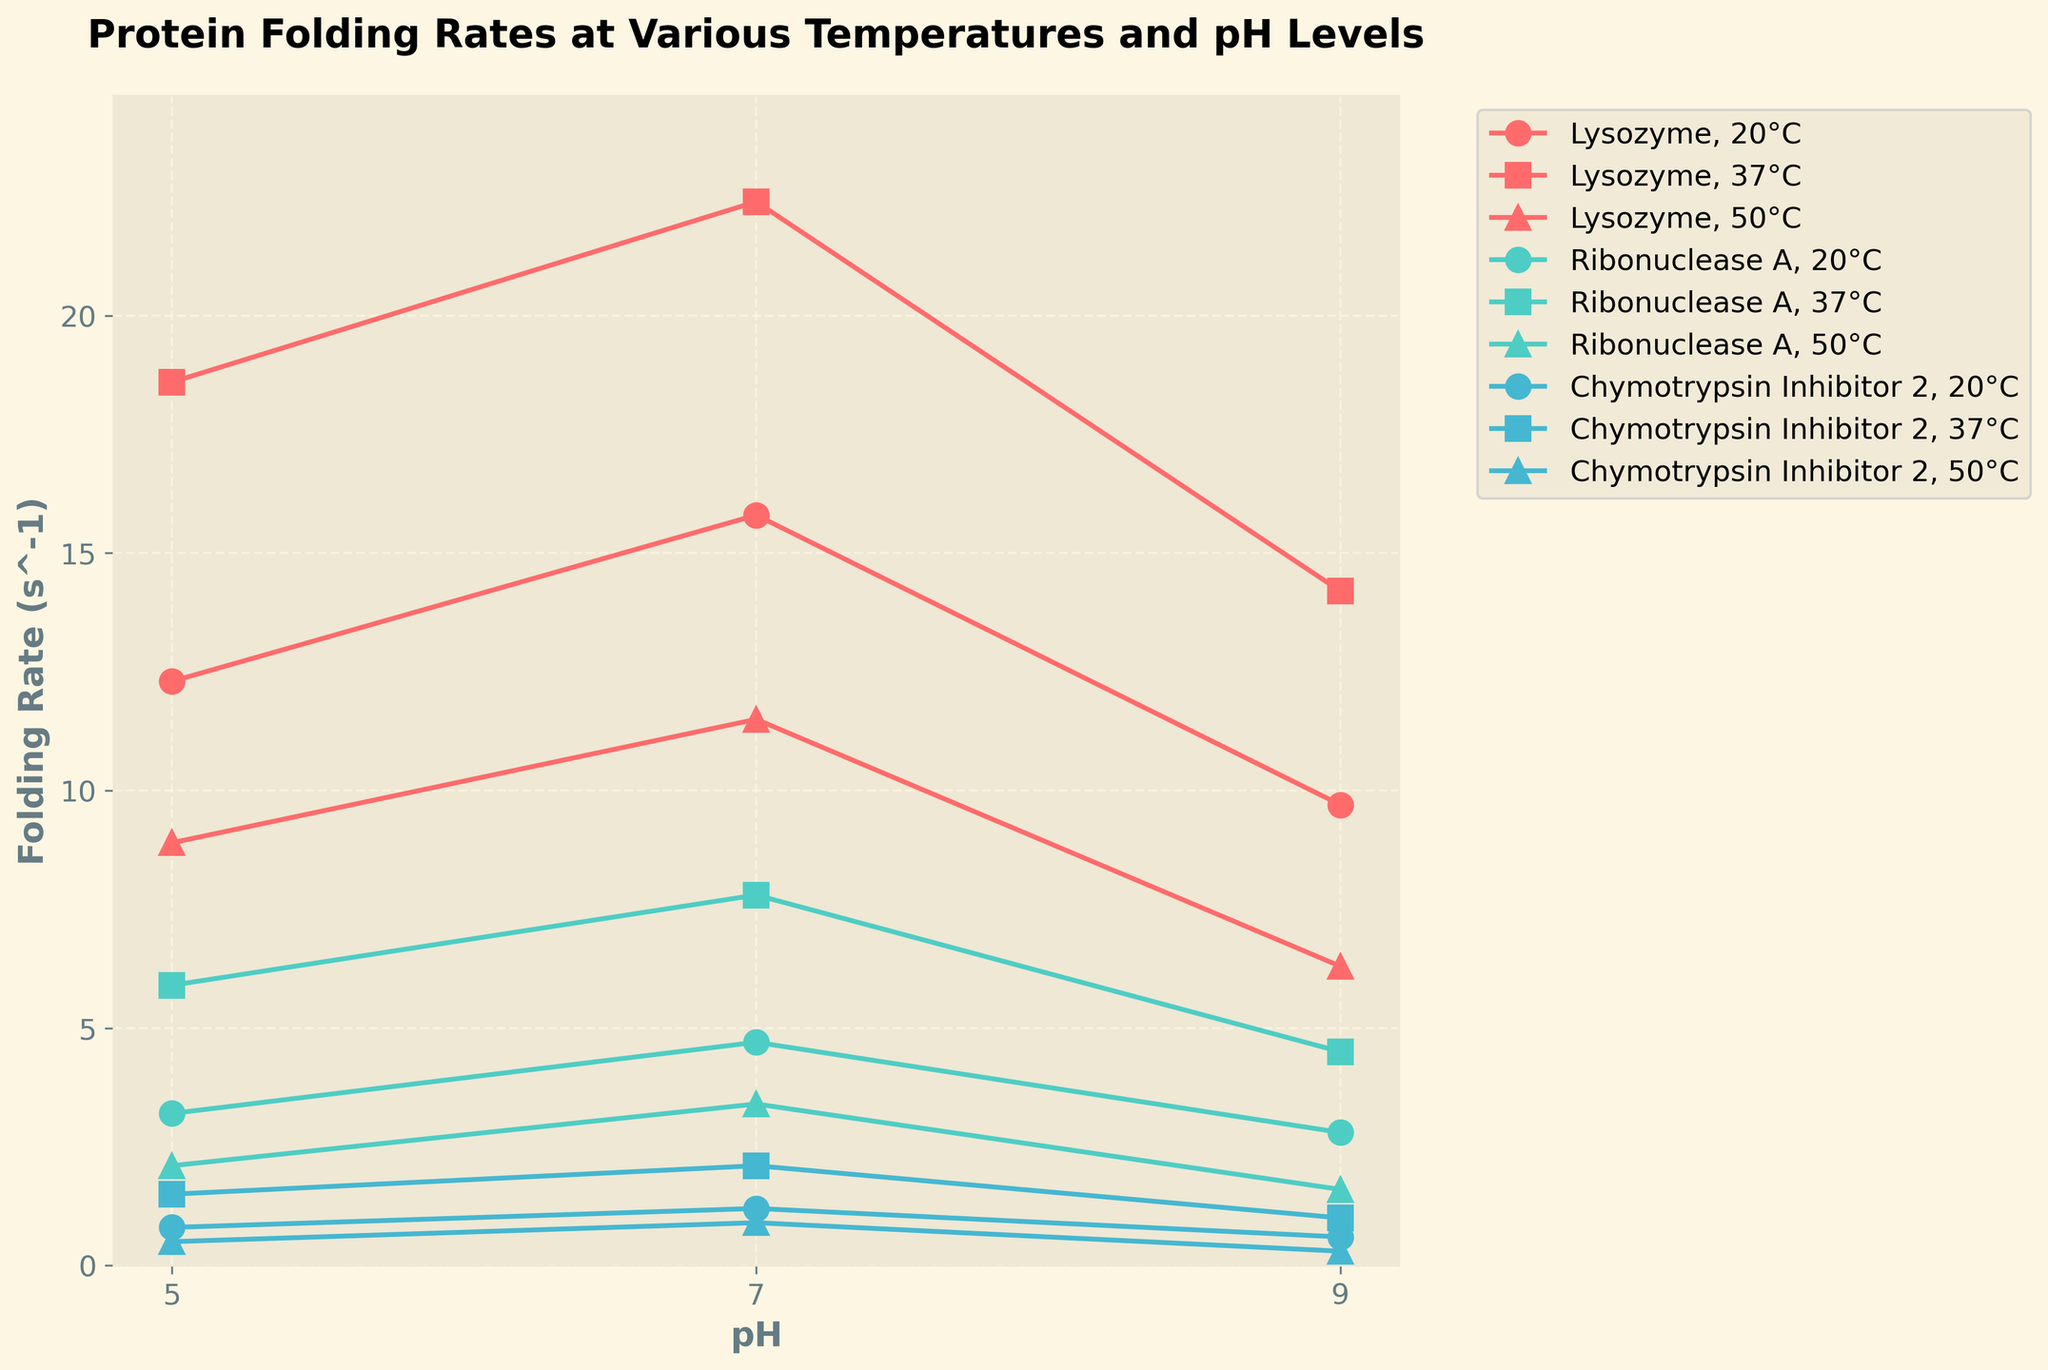What's the highest folding rate observed for Lysozyme at 37°C? First, locate the curve for Lysozyme at 37°C, indicated by its color and marker. Then, identify the peak value on the y-axis corresponding to pH levels. The highest folding rate at 37°C for Lysozyme is 22.4 s^-1 at pH 7.0.
Answer: 22.4 s^-1 How does the folding rate of Ribonuclease A at pH 5.0 change with temperature? Examine the folding rates for Ribonuclease A at pH 5.0 across different temperatures. At 20°C, the rate is 3.2 s^-1; at 37°C, it is 5.9 s^-1, and at 50°C, it drops to 2.1 s^-1. Thus, the rate increases from 20°C to 37°C and then decreases at 50°C.
Answer: Increases, then decreases Which protein has the lowest folding rate at 50°C and pH 9.0? Identify the data points for each protein at 50°C and pH 9.0. Compare the folding rates. The lowest value is for Chymotrypsin Inhibitor 2, with a rate of 0.3 s^-1.
Answer: Chymotrypsin Inhibitor 2 Compare the folding rates of Chymotrypsin Inhibitor 2 at 20°C and 37°C across different pH levels. Compare the lines for Chymotrypsin Inhibitor 2 at 20°C and 37°C. At pH 5.0, the rates are 0.8 s^-1 and 1.5 s^-1, respectively. At pH 7.0, they are 1.2 s^-1 and 2.1 s^-1, and at pH 9.0, they are 0.6 s^-1 and 1.0 s^-1. The folding rates are consistently higher at 37°C across all pH levels.
Answer: Higher at 37°C What is the median folding rate of Lysozyme at 37°C? There are three data points for Lysozyme at 37°C: 18.6 s^-1, 22.4 s^-1, and 14.2 s^-1. Arrange them in ascending order: 14.2, 18.6, 22.4. The median is the middle value, which is 18.6 s^-1.
Answer: 18.6 s^-1 Find the average folding rate of Ribonuclease A at 20°C. Add the folding rates of Ribonuclease A at 20°C: 3.2 s^-1 + 4.7 s^-1 + 2.8 s^-1 = 10.7 s^-1. Divide by the number of data points (3). The average folding rate is 10.7 / 3 = 3.57 s^-1.
Answer: 3.57 s^-1 Which protein shows the largest variation in folding rates at 50°C across different pH levels? Determine the range of folding rates for each protein at 50°C by subtracting the minimum rate from the maximum rate. For Lysozyme, the range is 8.9 - 6.3 = 2.6 s^-1. For Ribonuclease A, it is 3.4 - 1.6 = 1.8 s^-1. For Chymotrypsin Inhibitor 2, it is 0.9 - 0.3 = 0.6 s^-1. Lysozyme has the largest variation.
Answer: Lysozyme How does the folding rate of Lysozyme at 20°C compare to Ribonuclease A at the same temperature and pH 7.0? Look at the folding rates for both proteins at 20°C and pH 7.0. Lysozyme has a rate of 15.8 s^-1 and Ribonuclease A has a rate of 4.7 s^-1. Lysozyme's folding rate is significantly higher.
Answer: Lysozyme's rate is higher Identify the pH level at which Ribonuclease A has the highest folding rate at 37°C Find the folding rates for Ribonuclease A at 37°C across different pH levels: 5.0, 7.0, and 9.0. The rates are 5.9 s^-1, 7.8 s^-1, and 4.5 s^-1. The highest rate is at pH 7.0.
Answer: pH 7.0 